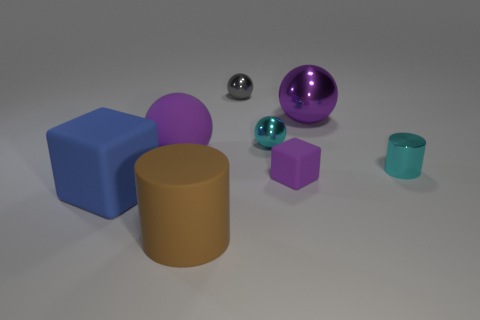How many large green cubes are the same material as the blue object?
Make the answer very short. 0. There is a small thing that is the same color as the large metallic sphere; what is its shape?
Offer a very short reply. Cube. Is there another thing of the same shape as the brown thing?
Provide a succinct answer. Yes. What is the shape of the blue rubber object that is the same size as the rubber cylinder?
Your response must be concise. Cube. Is the color of the small matte cube the same as the matte block that is left of the tiny purple thing?
Keep it short and to the point. No. There is a large purple object in front of the large metal ball; how many large brown things are left of it?
Make the answer very short. 0. What is the size of the matte object that is both left of the tiny purple rubber object and behind the big blue matte object?
Offer a terse response. Large. Are there any red matte objects that have the same size as the gray sphere?
Make the answer very short. No. Is the number of small cyan things that are behind the large purple metal ball greater than the number of tiny cyan objects in front of the small cyan metal cylinder?
Your answer should be very brief. No. Are the large brown object and the small object on the left side of the small cyan metal sphere made of the same material?
Your response must be concise. No. 